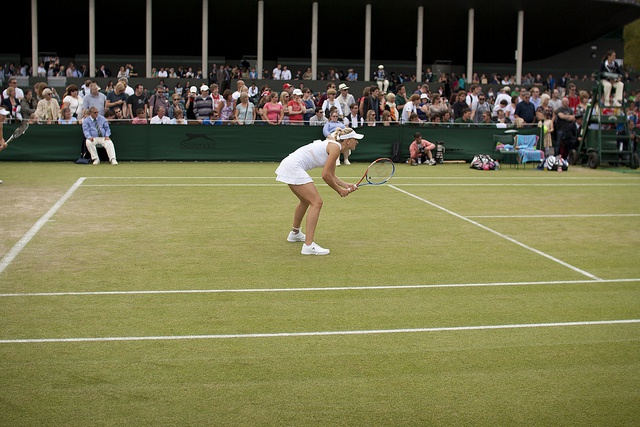Describe the objects in this image and their specific colors. I can see people in black, gray, and darkgray tones, people in black, lavender, gray, tan, and maroon tones, people in black, lightgray, darkgray, and gray tones, tennis racket in black, olive, darkgray, and gray tones, and chair in black, lightblue, and gray tones in this image. 